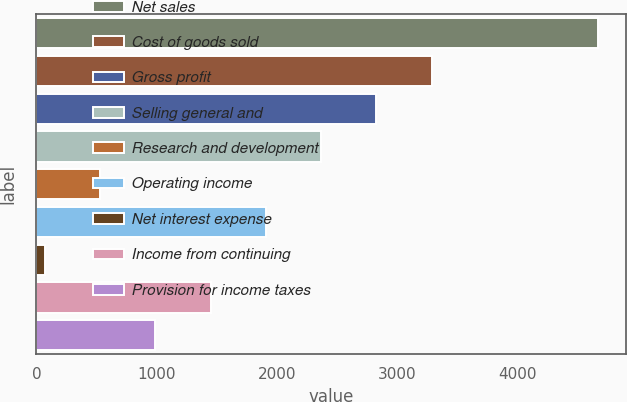Convert chart to OTSL. <chart><loc_0><loc_0><loc_500><loc_500><bar_chart><fcel>Net sales<fcel>Cost of goods sold<fcel>Gross profit<fcel>Selling general and<fcel>Research and development<fcel>Operating income<fcel>Net interest expense<fcel>Income from continuing<fcel>Provision for income taxes<nl><fcel>4666.8<fcel>3287.34<fcel>2827.52<fcel>2367.7<fcel>528.42<fcel>1907.88<fcel>68.6<fcel>1448.06<fcel>988.24<nl></chart> 